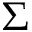<formula> <loc_0><loc_0><loc_500><loc_500>\Sigma</formula> 